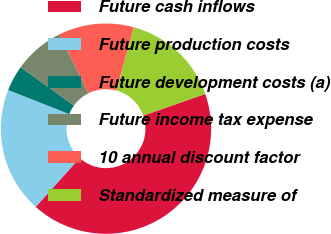Convert chart to OTSL. <chart><loc_0><loc_0><loc_500><loc_500><pie_chart><fcel>Future cash inflows<fcel>Future production costs<fcel>Future development costs (a)<fcel>Future income tax expense<fcel>10 annual discount factor<fcel>Standardized measure of<nl><fcel>42.01%<fcel>19.34%<fcel>3.96%<fcel>7.76%<fcel>11.57%<fcel>15.37%<nl></chart> 